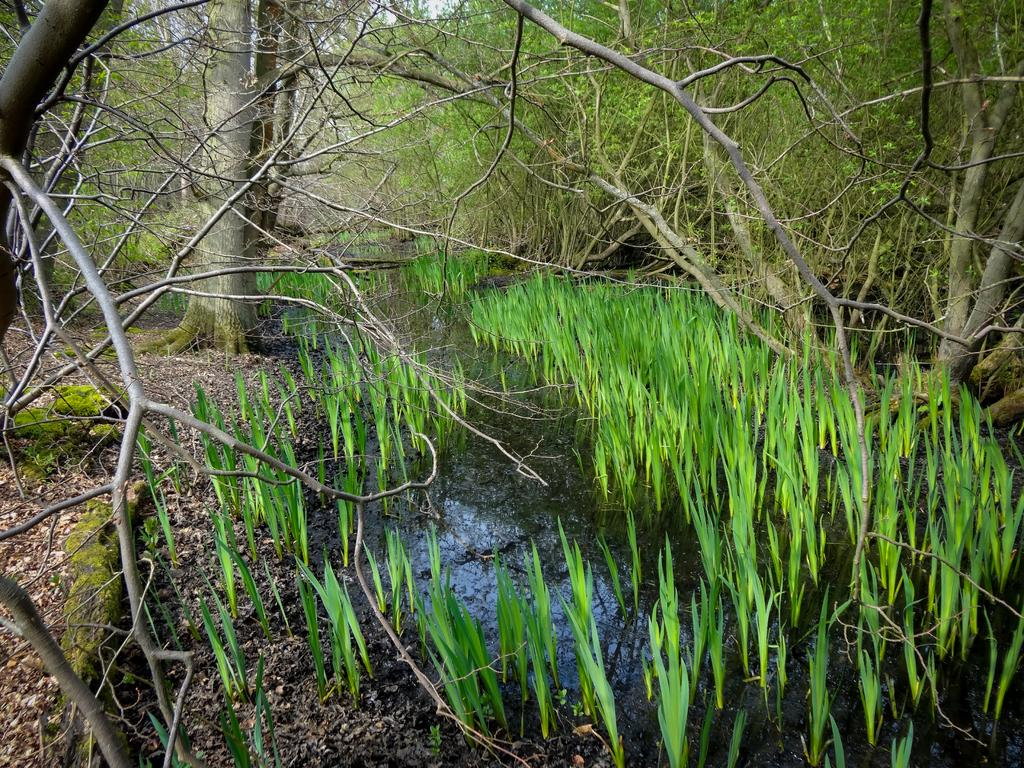What is present at the bottom of the picture? Dry leaves and twigs are present at the bottom of the picture. What can be seen in the image besides the dry leaves and twigs? There is water visible in the image. What might be the source of the water in the image? The water might be in a pond. What type of vegetation is present in the water? Grass is present in the water. What can be seen in the background of the image? There are trees in the background of the image. Can you see a fan in the image? There is no fan present in the image. Is there a boat visible in the water? There is no boat visible in the water; only grass is present in the water. 